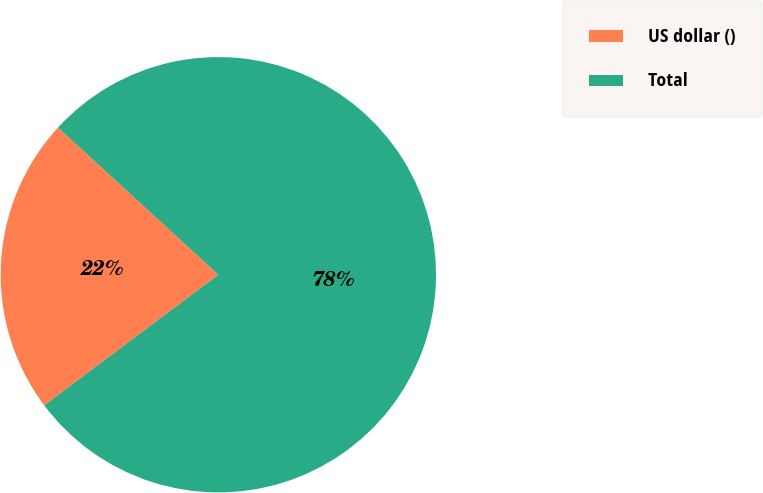Convert chart. <chart><loc_0><loc_0><loc_500><loc_500><pie_chart><fcel>US dollar ()<fcel>Total<nl><fcel>22.06%<fcel>77.94%<nl></chart> 